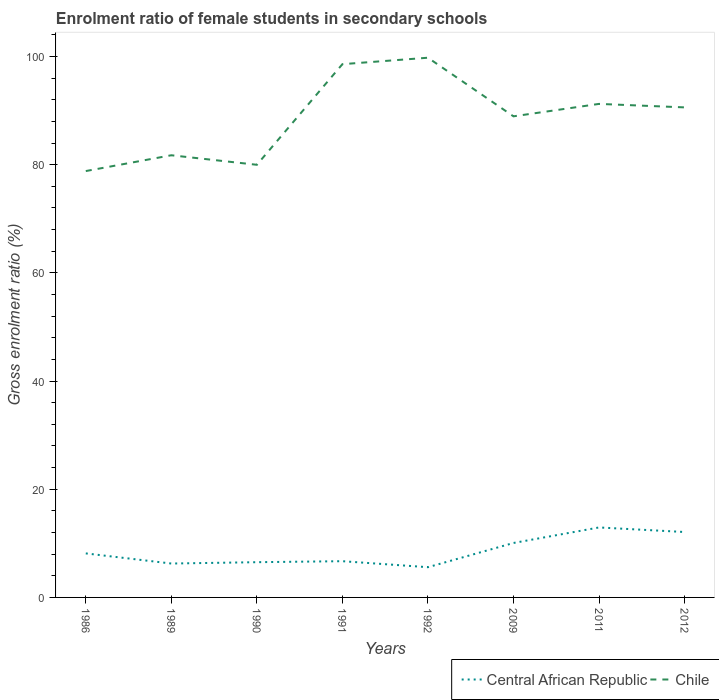How many different coloured lines are there?
Offer a terse response. 2. Is the number of lines equal to the number of legend labels?
Keep it short and to the point. Yes. Across all years, what is the maximum enrolment ratio of female students in secondary schools in Central African Republic?
Your response must be concise. 5.59. In which year was the enrolment ratio of female students in secondary schools in Chile maximum?
Offer a terse response. 1986. What is the total enrolment ratio of female students in secondary schools in Chile in the graph?
Make the answer very short. -10.12. What is the difference between the highest and the second highest enrolment ratio of female students in secondary schools in Chile?
Your answer should be very brief. 20.95. What is the difference between the highest and the lowest enrolment ratio of female students in secondary schools in Chile?
Offer a terse response. 5. Is the enrolment ratio of female students in secondary schools in Central African Republic strictly greater than the enrolment ratio of female students in secondary schools in Chile over the years?
Provide a succinct answer. Yes. Does the graph contain grids?
Your response must be concise. No. Where does the legend appear in the graph?
Your response must be concise. Bottom right. How many legend labels are there?
Ensure brevity in your answer.  2. What is the title of the graph?
Give a very brief answer. Enrolment ratio of female students in secondary schools. Does "Euro area" appear as one of the legend labels in the graph?
Keep it short and to the point. No. What is the label or title of the Y-axis?
Ensure brevity in your answer.  Gross enrolment ratio (%). What is the Gross enrolment ratio (%) in Central African Republic in 1986?
Offer a very short reply. 8.14. What is the Gross enrolment ratio (%) in Chile in 1986?
Keep it short and to the point. 78.81. What is the Gross enrolment ratio (%) in Central African Republic in 1989?
Ensure brevity in your answer.  6.27. What is the Gross enrolment ratio (%) in Chile in 1989?
Offer a terse response. 81.74. What is the Gross enrolment ratio (%) of Central African Republic in 1990?
Your answer should be very brief. 6.51. What is the Gross enrolment ratio (%) of Chile in 1990?
Ensure brevity in your answer.  79.97. What is the Gross enrolment ratio (%) in Central African Republic in 1991?
Ensure brevity in your answer.  6.7. What is the Gross enrolment ratio (%) in Chile in 1991?
Provide a succinct answer. 98.57. What is the Gross enrolment ratio (%) in Central African Republic in 1992?
Make the answer very short. 5.59. What is the Gross enrolment ratio (%) in Chile in 1992?
Ensure brevity in your answer.  99.77. What is the Gross enrolment ratio (%) in Central African Republic in 2009?
Give a very brief answer. 10.07. What is the Gross enrolment ratio (%) of Chile in 2009?
Keep it short and to the point. 88.93. What is the Gross enrolment ratio (%) in Central African Republic in 2011?
Your answer should be compact. 12.93. What is the Gross enrolment ratio (%) of Chile in 2011?
Ensure brevity in your answer.  91.23. What is the Gross enrolment ratio (%) of Central African Republic in 2012?
Make the answer very short. 12.09. What is the Gross enrolment ratio (%) of Chile in 2012?
Offer a very short reply. 90.59. Across all years, what is the maximum Gross enrolment ratio (%) of Central African Republic?
Your answer should be compact. 12.93. Across all years, what is the maximum Gross enrolment ratio (%) in Chile?
Make the answer very short. 99.77. Across all years, what is the minimum Gross enrolment ratio (%) in Central African Republic?
Give a very brief answer. 5.59. Across all years, what is the minimum Gross enrolment ratio (%) in Chile?
Make the answer very short. 78.81. What is the total Gross enrolment ratio (%) of Central African Republic in the graph?
Provide a succinct answer. 68.3. What is the total Gross enrolment ratio (%) in Chile in the graph?
Offer a very short reply. 709.61. What is the difference between the Gross enrolment ratio (%) in Central African Republic in 1986 and that in 1989?
Keep it short and to the point. 1.87. What is the difference between the Gross enrolment ratio (%) of Chile in 1986 and that in 1989?
Ensure brevity in your answer.  -2.92. What is the difference between the Gross enrolment ratio (%) in Central African Republic in 1986 and that in 1990?
Your answer should be very brief. 1.62. What is the difference between the Gross enrolment ratio (%) in Chile in 1986 and that in 1990?
Offer a terse response. -1.16. What is the difference between the Gross enrolment ratio (%) of Central African Republic in 1986 and that in 1991?
Make the answer very short. 1.44. What is the difference between the Gross enrolment ratio (%) of Chile in 1986 and that in 1991?
Offer a very short reply. -19.76. What is the difference between the Gross enrolment ratio (%) of Central African Republic in 1986 and that in 1992?
Provide a succinct answer. 2.55. What is the difference between the Gross enrolment ratio (%) in Chile in 1986 and that in 1992?
Provide a succinct answer. -20.95. What is the difference between the Gross enrolment ratio (%) of Central African Republic in 1986 and that in 2009?
Make the answer very short. -1.93. What is the difference between the Gross enrolment ratio (%) of Chile in 1986 and that in 2009?
Keep it short and to the point. -10.12. What is the difference between the Gross enrolment ratio (%) of Central African Republic in 1986 and that in 2011?
Offer a very short reply. -4.8. What is the difference between the Gross enrolment ratio (%) in Chile in 1986 and that in 2011?
Provide a succinct answer. -12.42. What is the difference between the Gross enrolment ratio (%) in Central African Republic in 1986 and that in 2012?
Your answer should be compact. -3.96. What is the difference between the Gross enrolment ratio (%) in Chile in 1986 and that in 2012?
Your answer should be compact. -11.77. What is the difference between the Gross enrolment ratio (%) in Central African Republic in 1989 and that in 1990?
Offer a terse response. -0.25. What is the difference between the Gross enrolment ratio (%) of Chile in 1989 and that in 1990?
Your answer should be compact. 1.76. What is the difference between the Gross enrolment ratio (%) of Central African Republic in 1989 and that in 1991?
Provide a succinct answer. -0.43. What is the difference between the Gross enrolment ratio (%) in Chile in 1989 and that in 1991?
Your answer should be very brief. -16.84. What is the difference between the Gross enrolment ratio (%) of Central African Republic in 1989 and that in 1992?
Your answer should be very brief. 0.68. What is the difference between the Gross enrolment ratio (%) of Chile in 1989 and that in 1992?
Give a very brief answer. -18.03. What is the difference between the Gross enrolment ratio (%) in Central African Republic in 1989 and that in 2009?
Ensure brevity in your answer.  -3.8. What is the difference between the Gross enrolment ratio (%) in Chile in 1989 and that in 2009?
Your answer should be very brief. -7.2. What is the difference between the Gross enrolment ratio (%) in Central African Republic in 1989 and that in 2011?
Give a very brief answer. -6.67. What is the difference between the Gross enrolment ratio (%) of Chile in 1989 and that in 2011?
Your response must be concise. -9.49. What is the difference between the Gross enrolment ratio (%) in Central African Republic in 1989 and that in 2012?
Keep it short and to the point. -5.83. What is the difference between the Gross enrolment ratio (%) in Chile in 1989 and that in 2012?
Offer a terse response. -8.85. What is the difference between the Gross enrolment ratio (%) in Central African Republic in 1990 and that in 1991?
Offer a terse response. -0.18. What is the difference between the Gross enrolment ratio (%) in Chile in 1990 and that in 1991?
Keep it short and to the point. -18.6. What is the difference between the Gross enrolment ratio (%) of Central African Republic in 1990 and that in 1992?
Your answer should be very brief. 0.93. What is the difference between the Gross enrolment ratio (%) in Chile in 1990 and that in 1992?
Provide a succinct answer. -19.79. What is the difference between the Gross enrolment ratio (%) in Central African Republic in 1990 and that in 2009?
Your answer should be very brief. -3.55. What is the difference between the Gross enrolment ratio (%) of Chile in 1990 and that in 2009?
Give a very brief answer. -8.96. What is the difference between the Gross enrolment ratio (%) of Central African Republic in 1990 and that in 2011?
Ensure brevity in your answer.  -6.42. What is the difference between the Gross enrolment ratio (%) of Chile in 1990 and that in 2011?
Provide a short and direct response. -11.26. What is the difference between the Gross enrolment ratio (%) of Central African Republic in 1990 and that in 2012?
Provide a succinct answer. -5.58. What is the difference between the Gross enrolment ratio (%) of Chile in 1990 and that in 2012?
Make the answer very short. -10.61. What is the difference between the Gross enrolment ratio (%) of Central African Republic in 1991 and that in 1992?
Your answer should be very brief. 1.11. What is the difference between the Gross enrolment ratio (%) in Chile in 1991 and that in 1992?
Give a very brief answer. -1.19. What is the difference between the Gross enrolment ratio (%) in Central African Republic in 1991 and that in 2009?
Provide a succinct answer. -3.37. What is the difference between the Gross enrolment ratio (%) of Chile in 1991 and that in 2009?
Ensure brevity in your answer.  9.64. What is the difference between the Gross enrolment ratio (%) in Central African Republic in 1991 and that in 2011?
Your answer should be very brief. -6.24. What is the difference between the Gross enrolment ratio (%) in Chile in 1991 and that in 2011?
Give a very brief answer. 7.34. What is the difference between the Gross enrolment ratio (%) of Central African Republic in 1991 and that in 2012?
Offer a very short reply. -5.4. What is the difference between the Gross enrolment ratio (%) of Chile in 1991 and that in 2012?
Ensure brevity in your answer.  7.99. What is the difference between the Gross enrolment ratio (%) in Central African Republic in 1992 and that in 2009?
Keep it short and to the point. -4.48. What is the difference between the Gross enrolment ratio (%) of Chile in 1992 and that in 2009?
Provide a succinct answer. 10.83. What is the difference between the Gross enrolment ratio (%) in Central African Republic in 1992 and that in 2011?
Your answer should be compact. -7.35. What is the difference between the Gross enrolment ratio (%) in Chile in 1992 and that in 2011?
Provide a succinct answer. 8.54. What is the difference between the Gross enrolment ratio (%) of Central African Republic in 1992 and that in 2012?
Give a very brief answer. -6.51. What is the difference between the Gross enrolment ratio (%) of Chile in 1992 and that in 2012?
Offer a very short reply. 9.18. What is the difference between the Gross enrolment ratio (%) of Central African Republic in 2009 and that in 2011?
Keep it short and to the point. -2.87. What is the difference between the Gross enrolment ratio (%) of Chile in 2009 and that in 2011?
Keep it short and to the point. -2.3. What is the difference between the Gross enrolment ratio (%) of Central African Republic in 2009 and that in 2012?
Your answer should be compact. -2.03. What is the difference between the Gross enrolment ratio (%) of Chile in 2009 and that in 2012?
Keep it short and to the point. -1.65. What is the difference between the Gross enrolment ratio (%) of Central African Republic in 2011 and that in 2012?
Keep it short and to the point. 0.84. What is the difference between the Gross enrolment ratio (%) in Chile in 2011 and that in 2012?
Offer a terse response. 0.65. What is the difference between the Gross enrolment ratio (%) in Central African Republic in 1986 and the Gross enrolment ratio (%) in Chile in 1989?
Make the answer very short. -73.6. What is the difference between the Gross enrolment ratio (%) in Central African Republic in 1986 and the Gross enrolment ratio (%) in Chile in 1990?
Offer a very short reply. -71.84. What is the difference between the Gross enrolment ratio (%) of Central African Republic in 1986 and the Gross enrolment ratio (%) of Chile in 1991?
Ensure brevity in your answer.  -90.44. What is the difference between the Gross enrolment ratio (%) of Central African Republic in 1986 and the Gross enrolment ratio (%) of Chile in 1992?
Provide a short and direct response. -91.63. What is the difference between the Gross enrolment ratio (%) in Central African Republic in 1986 and the Gross enrolment ratio (%) in Chile in 2009?
Your answer should be compact. -80.79. What is the difference between the Gross enrolment ratio (%) of Central African Republic in 1986 and the Gross enrolment ratio (%) of Chile in 2011?
Offer a very short reply. -83.09. What is the difference between the Gross enrolment ratio (%) in Central African Republic in 1986 and the Gross enrolment ratio (%) in Chile in 2012?
Offer a terse response. -82.45. What is the difference between the Gross enrolment ratio (%) in Central African Republic in 1989 and the Gross enrolment ratio (%) in Chile in 1990?
Make the answer very short. -73.71. What is the difference between the Gross enrolment ratio (%) of Central African Republic in 1989 and the Gross enrolment ratio (%) of Chile in 1991?
Ensure brevity in your answer.  -92.31. What is the difference between the Gross enrolment ratio (%) in Central African Republic in 1989 and the Gross enrolment ratio (%) in Chile in 1992?
Ensure brevity in your answer.  -93.5. What is the difference between the Gross enrolment ratio (%) of Central African Republic in 1989 and the Gross enrolment ratio (%) of Chile in 2009?
Provide a succinct answer. -82.67. What is the difference between the Gross enrolment ratio (%) of Central African Republic in 1989 and the Gross enrolment ratio (%) of Chile in 2011?
Provide a succinct answer. -84.97. What is the difference between the Gross enrolment ratio (%) in Central African Republic in 1989 and the Gross enrolment ratio (%) in Chile in 2012?
Give a very brief answer. -84.32. What is the difference between the Gross enrolment ratio (%) in Central African Republic in 1990 and the Gross enrolment ratio (%) in Chile in 1991?
Offer a very short reply. -92.06. What is the difference between the Gross enrolment ratio (%) of Central African Republic in 1990 and the Gross enrolment ratio (%) of Chile in 1992?
Keep it short and to the point. -93.25. What is the difference between the Gross enrolment ratio (%) of Central African Republic in 1990 and the Gross enrolment ratio (%) of Chile in 2009?
Provide a succinct answer. -82.42. What is the difference between the Gross enrolment ratio (%) of Central African Republic in 1990 and the Gross enrolment ratio (%) of Chile in 2011?
Make the answer very short. -84.72. What is the difference between the Gross enrolment ratio (%) of Central African Republic in 1990 and the Gross enrolment ratio (%) of Chile in 2012?
Offer a very short reply. -84.07. What is the difference between the Gross enrolment ratio (%) in Central African Republic in 1991 and the Gross enrolment ratio (%) in Chile in 1992?
Offer a very short reply. -93.07. What is the difference between the Gross enrolment ratio (%) of Central African Republic in 1991 and the Gross enrolment ratio (%) of Chile in 2009?
Ensure brevity in your answer.  -82.23. What is the difference between the Gross enrolment ratio (%) in Central African Republic in 1991 and the Gross enrolment ratio (%) in Chile in 2011?
Provide a short and direct response. -84.53. What is the difference between the Gross enrolment ratio (%) of Central African Republic in 1991 and the Gross enrolment ratio (%) of Chile in 2012?
Offer a very short reply. -83.89. What is the difference between the Gross enrolment ratio (%) of Central African Republic in 1992 and the Gross enrolment ratio (%) of Chile in 2009?
Provide a short and direct response. -83.34. What is the difference between the Gross enrolment ratio (%) of Central African Republic in 1992 and the Gross enrolment ratio (%) of Chile in 2011?
Give a very brief answer. -85.64. What is the difference between the Gross enrolment ratio (%) of Central African Republic in 1992 and the Gross enrolment ratio (%) of Chile in 2012?
Provide a short and direct response. -85. What is the difference between the Gross enrolment ratio (%) in Central African Republic in 2009 and the Gross enrolment ratio (%) in Chile in 2011?
Offer a very short reply. -81.17. What is the difference between the Gross enrolment ratio (%) of Central African Republic in 2009 and the Gross enrolment ratio (%) of Chile in 2012?
Keep it short and to the point. -80.52. What is the difference between the Gross enrolment ratio (%) of Central African Republic in 2011 and the Gross enrolment ratio (%) of Chile in 2012?
Your answer should be compact. -77.65. What is the average Gross enrolment ratio (%) in Central African Republic per year?
Give a very brief answer. 8.54. What is the average Gross enrolment ratio (%) in Chile per year?
Offer a terse response. 88.7. In the year 1986, what is the difference between the Gross enrolment ratio (%) in Central African Republic and Gross enrolment ratio (%) in Chile?
Make the answer very short. -70.68. In the year 1989, what is the difference between the Gross enrolment ratio (%) in Central African Republic and Gross enrolment ratio (%) in Chile?
Provide a short and direct response. -75.47. In the year 1990, what is the difference between the Gross enrolment ratio (%) of Central African Republic and Gross enrolment ratio (%) of Chile?
Provide a short and direct response. -73.46. In the year 1991, what is the difference between the Gross enrolment ratio (%) in Central African Republic and Gross enrolment ratio (%) in Chile?
Make the answer very short. -91.88. In the year 1992, what is the difference between the Gross enrolment ratio (%) of Central African Republic and Gross enrolment ratio (%) of Chile?
Provide a succinct answer. -94.18. In the year 2009, what is the difference between the Gross enrolment ratio (%) in Central African Republic and Gross enrolment ratio (%) in Chile?
Your answer should be compact. -78.87. In the year 2011, what is the difference between the Gross enrolment ratio (%) of Central African Republic and Gross enrolment ratio (%) of Chile?
Offer a terse response. -78.3. In the year 2012, what is the difference between the Gross enrolment ratio (%) in Central African Republic and Gross enrolment ratio (%) in Chile?
Your response must be concise. -78.49. What is the ratio of the Gross enrolment ratio (%) in Central African Republic in 1986 to that in 1989?
Provide a short and direct response. 1.3. What is the ratio of the Gross enrolment ratio (%) in Central African Republic in 1986 to that in 1990?
Ensure brevity in your answer.  1.25. What is the ratio of the Gross enrolment ratio (%) of Chile in 1986 to that in 1990?
Keep it short and to the point. 0.99. What is the ratio of the Gross enrolment ratio (%) of Central African Republic in 1986 to that in 1991?
Make the answer very short. 1.22. What is the ratio of the Gross enrolment ratio (%) in Chile in 1986 to that in 1991?
Your answer should be compact. 0.8. What is the ratio of the Gross enrolment ratio (%) in Central African Republic in 1986 to that in 1992?
Provide a succinct answer. 1.46. What is the ratio of the Gross enrolment ratio (%) of Chile in 1986 to that in 1992?
Make the answer very short. 0.79. What is the ratio of the Gross enrolment ratio (%) in Central African Republic in 1986 to that in 2009?
Your response must be concise. 0.81. What is the ratio of the Gross enrolment ratio (%) in Chile in 1986 to that in 2009?
Provide a succinct answer. 0.89. What is the ratio of the Gross enrolment ratio (%) in Central African Republic in 1986 to that in 2011?
Give a very brief answer. 0.63. What is the ratio of the Gross enrolment ratio (%) in Chile in 1986 to that in 2011?
Ensure brevity in your answer.  0.86. What is the ratio of the Gross enrolment ratio (%) of Central African Republic in 1986 to that in 2012?
Make the answer very short. 0.67. What is the ratio of the Gross enrolment ratio (%) of Chile in 1986 to that in 2012?
Offer a terse response. 0.87. What is the ratio of the Gross enrolment ratio (%) in Central African Republic in 1989 to that in 1990?
Ensure brevity in your answer.  0.96. What is the ratio of the Gross enrolment ratio (%) in Chile in 1989 to that in 1990?
Your response must be concise. 1.02. What is the ratio of the Gross enrolment ratio (%) of Central African Republic in 1989 to that in 1991?
Your answer should be compact. 0.94. What is the ratio of the Gross enrolment ratio (%) in Chile in 1989 to that in 1991?
Keep it short and to the point. 0.83. What is the ratio of the Gross enrolment ratio (%) in Central African Republic in 1989 to that in 1992?
Ensure brevity in your answer.  1.12. What is the ratio of the Gross enrolment ratio (%) in Chile in 1989 to that in 1992?
Provide a succinct answer. 0.82. What is the ratio of the Gross enrolment ratio (%) of Central African Republic in 1989 to that in 2009?
Provide a short and direct response. 0.62. What is the ratio of the Gross enrolment ratio (%) of Chile in 1989 to that in 2009?
Provide a succinct answer. 0.92. What is the ratio of the Gross enrolment ratio (%) in Central African Republic in 1989 to that in 2011?
Your answer should be compact. 0.48. What is the ratio of the Gross enrolment ratio (%) of Chile in 1989 to that in 2011?
Your answer should be very brief. 0.9. What is the ratio of the Gross enrolment ratio (%) in Central African Republic in 1989 to that in 2012?
Keep it short and to the point. 0.52. What is the ratio of the Gross enrolment ratio (%) in Chile in 1989 to that in 2012?
Your answer should be very brief. 0.9. What is the ratio of the Gross enrolment ratio (%) of Central African Republic in 1990 to that in 1991?
Provide a short and direct response. 0.97. What is the ratio of the Gross enrolment ratio (%) in Chile in 1990 to that in 1991?
Your answer should be compact. 0.81. What is the ratio of the Gross enrolment ratio (%) of Central African Republic in 1990 to that in 1992?
Keep it short and to the point. 1.17. What is the ratio of the Gross enrolment ratio (%) in Chile in 1990 to that in 1992?
Offer a terse response. 0.8. What is the ratio of the Gross enrolment ratio (%) of Central African Republic in 1990 to that in 2009?
Make the answer very short. 0.65. What is the ratio of the Gross enrolment ratio (%) of Chile in 1990 to that in 2009?
Offer a terse response. 0.9. What is the ratio of the Gross enrolment ratio (%) in Central African Republic in 1990 to that in 2011?
Provide a succinct answer. 0.5. What is the ratio of the Gross enrolment ratio (%) in Chile in 1990 to that in 2011?
Provide a short and direct response. 0.88. What is the ratio of the Gross enrolment ratio (%) of Central African Republic in 1990 to that in 2012?
Ensure brevity in your answer.  0.54. What is the ratio of the Gross enrolment ratio (%) of Chile in 1990 to that in 2012?
Give a very brief answer. 0.88. What is the ratio of the Gross enrolment ratio (%) in Central African Republic in 1991 to that in 1992?
Provide a succinct answer. 1.2. What is the ratio of the Gross enrolment ratio (%) in Central African Republic in 1991 to that in 2009?
Make the answer very short. 0.67. What is the ratio of the Gross enrolment ratio (%) of Chile in 1991 to that in 2009?
Make the answer very short. 1.11. What is the ratio of the Gross enrolment ratio (%) in Central African Republic in 1991 to that in 2011?
Your answer should be compact. 0.52. What is the ratio of the Gross enrolment ratio (%) in Chile in 1991 to that in 2011?
Give a very brief answer. 1.08. What is the ratio of the Gross enrolment ratio (%) in Central African Republic in 1991 to that in 2012?
Your answer should be very brief. 0.55. What is the ratio of the Gross enrolment ratio (%) of Chile in 1991 to that in 2012?
Offer a terse response. 1.09. What is the ratio of the Gross enrolment ratio (%) in Central African Republic in 1992 to that in 2009?
Ensure brevity in your answer.  0.56. What is the ratio of the Gross enrolment ratio (%) of Chile in 1992 to that in 2009?
Give a very brief answer. 1.12. What is the ratio of the Gross enrolment ratio (%) in Central African Republic in 1992 to that in 2011?
Provide a short and direct response. 0.43. What is the ratio of the Gross enrolment ratio (%) of Chile in 1992 to that in 2011?
Provide a succinct answer. 1.09. What is the ratio of the Gross enrolment ratio (%) in Central African Republic in 1992 to that in 2012?
Provide a succinct answer. 0.46. What is the ratio of the Gross enrolment ratio (%) of Chile in 1992 to that in 2012?
Your answer should be compact. 1.1. What is the ratio of the Gross enrolment ratio (%) of Central African Republic in 2009 to that in 2011?
Offer a very short reply. 0.78. What is the ratio of the Gross enrolment ratio (%) of Chile in 2009 to that in 2011?
Provide a succinct answer. 0.97. What is the ratio of the Gross enrolment ratio (%) of Central African Republic in 2009 to that in 2012?
Offer a terse response. 0.83. What is the ratio of the Gross enrolment ratio (%) in Chile in 2009 to that in 2012?
Provide a short and direct response. 0.98. What is the ratio of the Gross enrolment ratio (%) of Central African Republic in 2011 to that in 2012?
Your answer should be compact. 1.07. What is the ratio of the Gross enrolment ratio (%) in Chile in 2011 to that in 2012?
Give a very brief answer. 1.01. What is the difference between the highest and the second highest Gross enrolment ratio (%) of Central African Republic?
Your answer should be compact. 0.84. What is the difference between the highest and the second highest Gross enrolment ratio (%) of Chile?
Your response must be concise. 1.19. What is the difference between the highest and the lowest Gross enrolment ratio (%) in Central African Republic?
Your answer should be very brief. 7.35. What is the difference between the highest and the lowest Gross enrolment ratio (%) of Chile?
Make the answer very short. 20.95. 